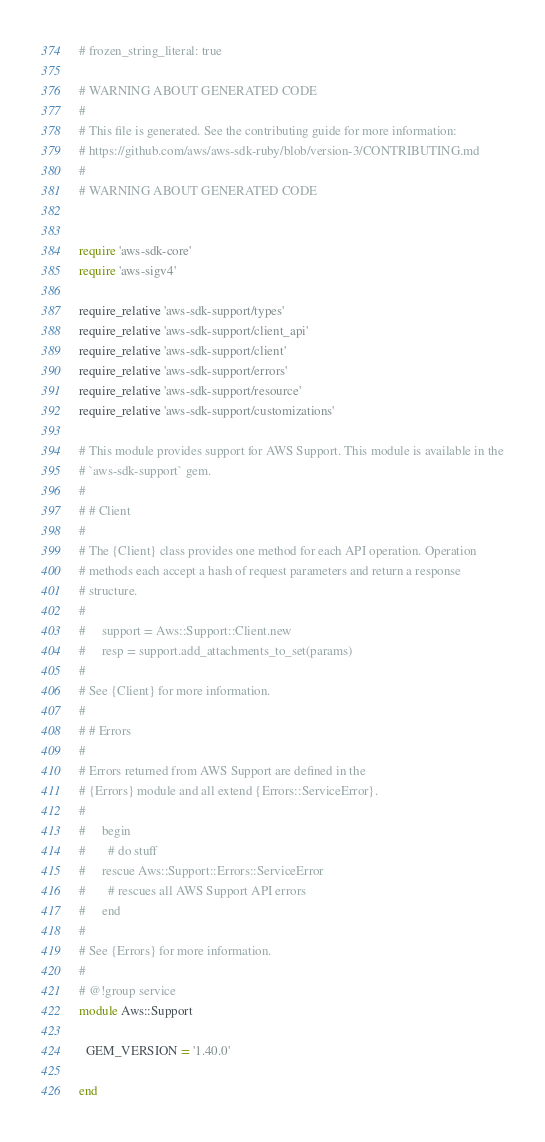Convert code to text. <code><loc_0><loc_0><loc_500><loc_500><_Ruby_># frozen_string_literal: true

# WARNING ABOUT GENERATED CODE
#
# This file is generated. See the contributing guide for more information:
# https://github.com/aws/aws-sdk-ruby/blob/version-3/CONTRIBUTING.md
#
# WARNING ABOUT GENERATED CODE


require 'aws-sdk-core'
require 'aws-sigv4'

require_relative 'aws-sdk-support/types'
require_relative 'aws-sdk-support/client_api'
require_relative 'aws-sdk-support/client'
require_relative 'aws-sdk-support/errors'
require_relative 'aws-sdk-support/resource'
require_relative 'aws-sdk-support/customizations'

# This module provides support for AWS Support. This module is available in the
# `aws-sdk-support` gem.
#
# # Client
#
# The {Client} class provides one method for each API operation. Operation
# methods each accept a hash of request parameters and return a response
# structure.
#
#     support = Aws::Support::Client.new
#     resp = support.add_attachments_to_set(params)
#
# See {Client} for more information.
#
# # Errors
#
# Errors returned from AWS Support are defined in the
# {Errors} module and all extend {Errors::ServiceError}.
#
#     begin
#       # do stuff
#     rescue Aws::Support::Errors::ServiceError
#       # rescues all AWS Support API errors
#     end
#
# See {Errors} for more information.
#
# @!group service
module Aws::Support

  GEM_VERSION = '1.40.0'

end
</code> 